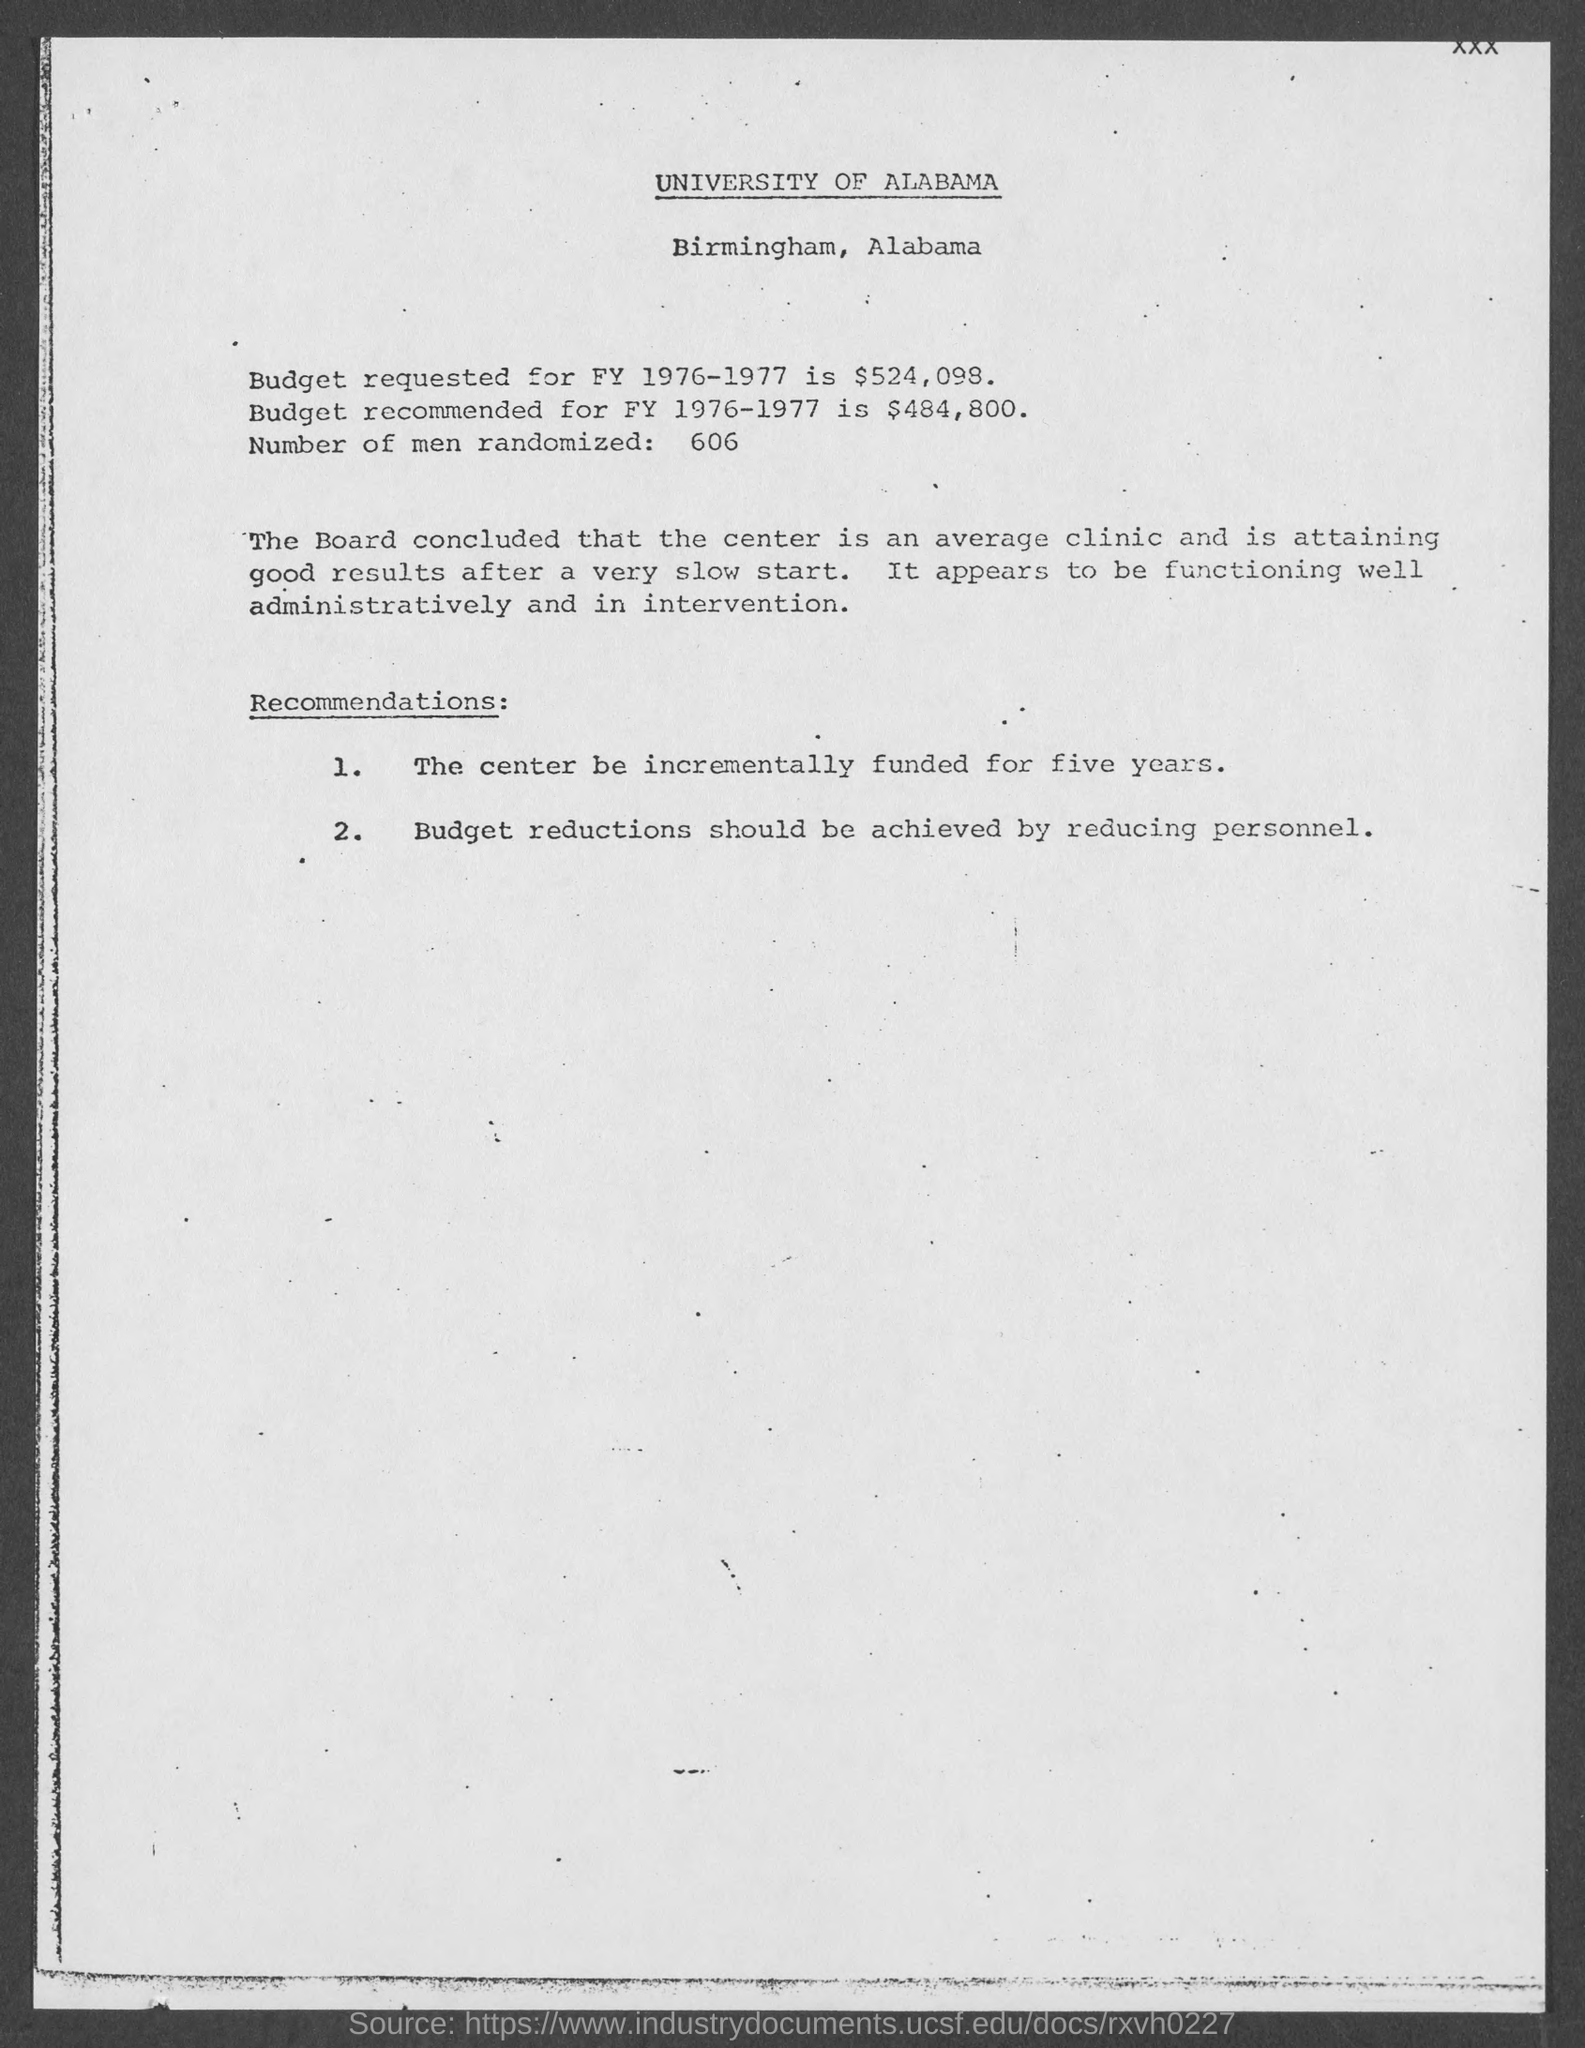What is the budget requested for FY 1976-1977?
Your answer should be very brief. $524,098. What is the budget recommended for FY 1976-1977?
Provide a short and direct response. $484,800. Which university is mentioned in this document?
Offer a very short reply. University of alabama. How many number of men randomized?
Your answer should be very brief. 606. Where University of Alabama is located?
Your answer should be very brief. Birmingham. 